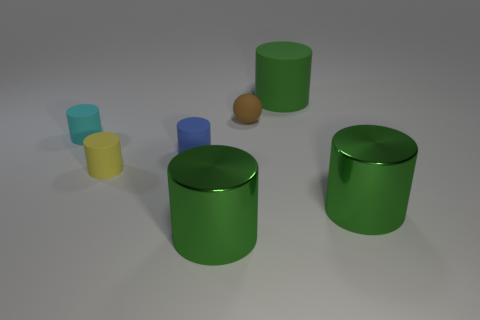Subtract all small yellow cylinders. How many cylinders are left? 5 Add 2 small brown rubber objects. How many objects exist? 9 Subtract 5 cylinders. How many cylinders are left? 1 Subtract all blue cylinders. How many cylinders are left? 5 Subtract all balls. How many objects are left? 6 Subtract all green cylinders. How many blue balls are left? 0 Add 3 blue objects. How many blue objects are left? 4 Add 6 large green shiny cylinders. How many large green shiny cylinders exist? 8 Subtract 0 yellow cubes. How many objects are left? 7 Subtract all blue cylinders. Subtract all brown blocks. How many cylinders are left? 5 